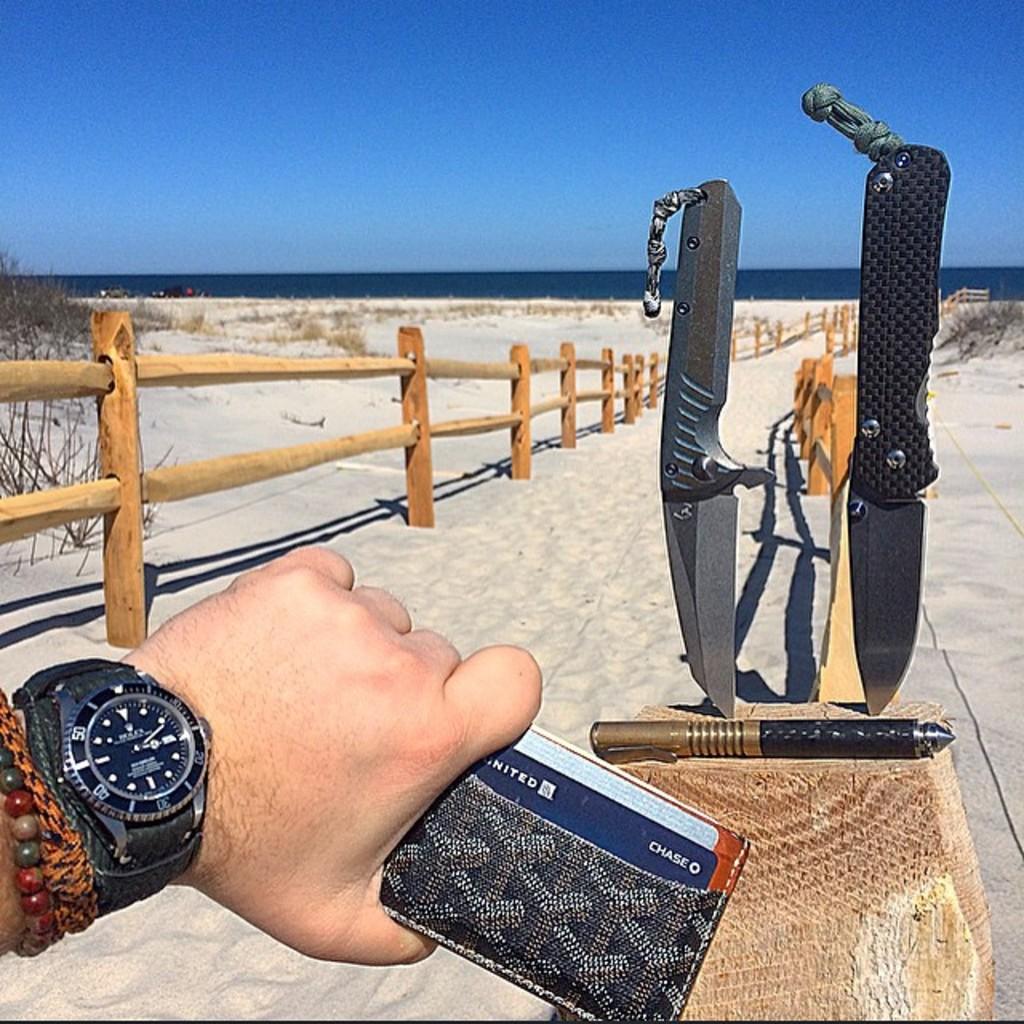What brand of watch?
Offer a terse response. Rolex. What is the company on the card in the wallet?
Your response must be concise. Chase. 